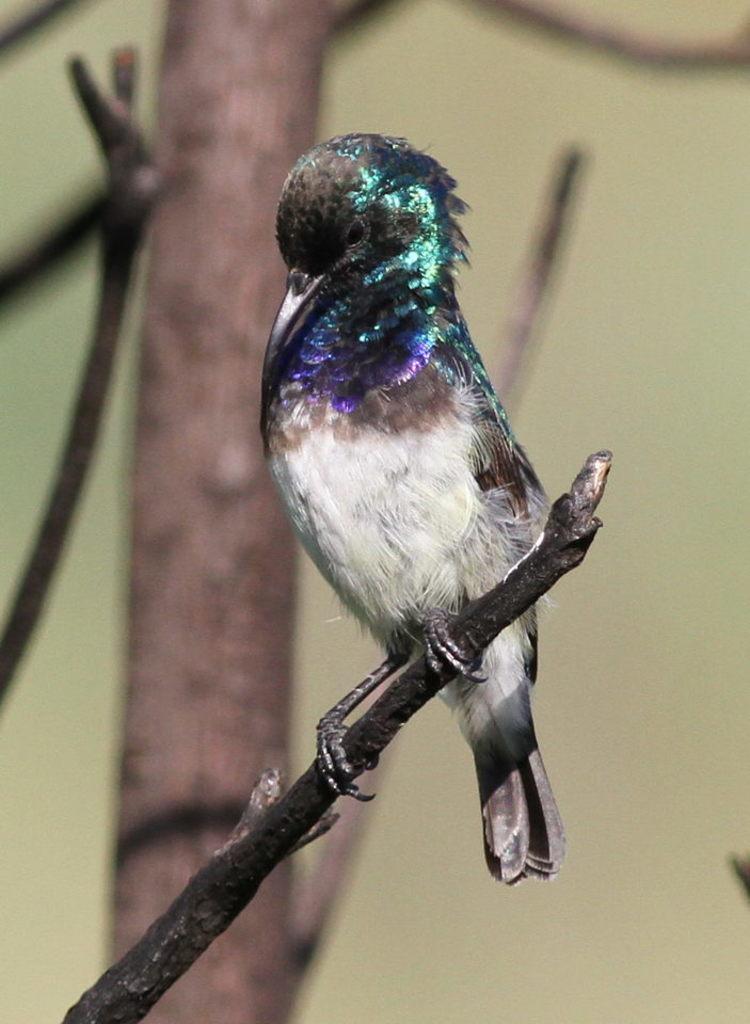How would you summarize this image in a sentence or two? In this image we can see a bird on the tree branch. 